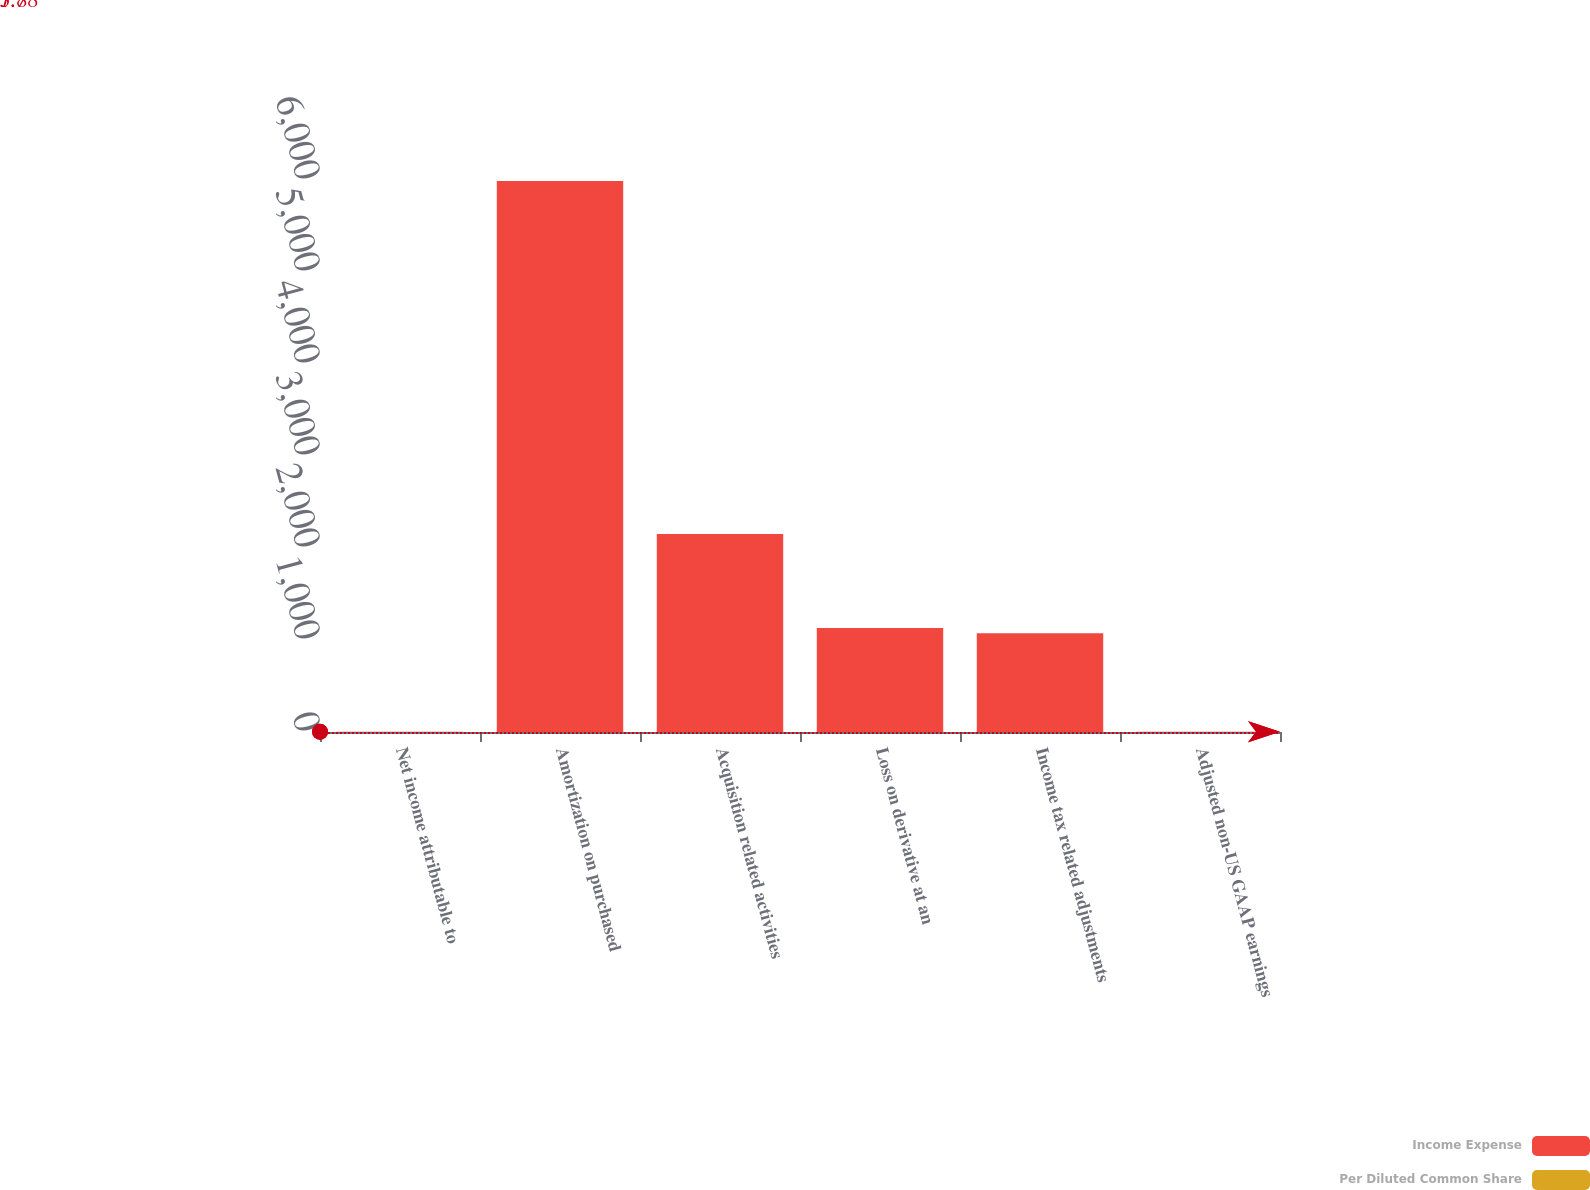<chart> <loc_0><loc_0><loc_500><loc_500><stacked_bar_chart><ecel><fcel>Net income attributable to<fcel>Amortization on purchased<fcel>Acquisition related activities<fcel>Loss on derivative at an<fcel>Income tax related adjustments<fcel>Adjusted non-US GAAP earnings<nl><fcel>Income Expense<fcel>1.88<fcel>5990<fcel>2152<fcel>1131<fcel>1073<fcel>1.88<nl><fcel>Per Diluted Common Share<fcel>1.82<fcel>0.04<fcel>0.01<fcel>0.01<fcel>0.01<fcel>1.94<nl></chart> 